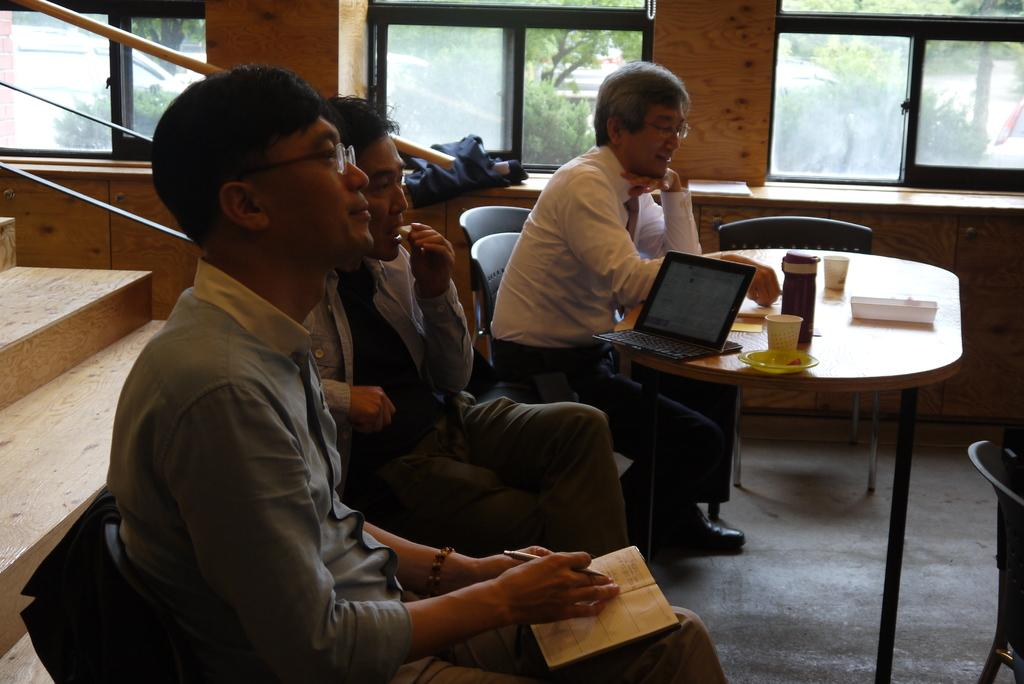How many people are sitting in the image? There are three persons sitting on chairs in the image. What can be seen on the table in the image? There is a laptop, a cup, a plate, and a bottle on the table in the image. What is visible in the background of the image? There is a window in the background, and trees are visible through the window. What type of fan is being used to cool down the room in the image? There is no fan visible in the image; it only shows three persons sitting on chairs, a table with various items, and a window with trees in the background. 